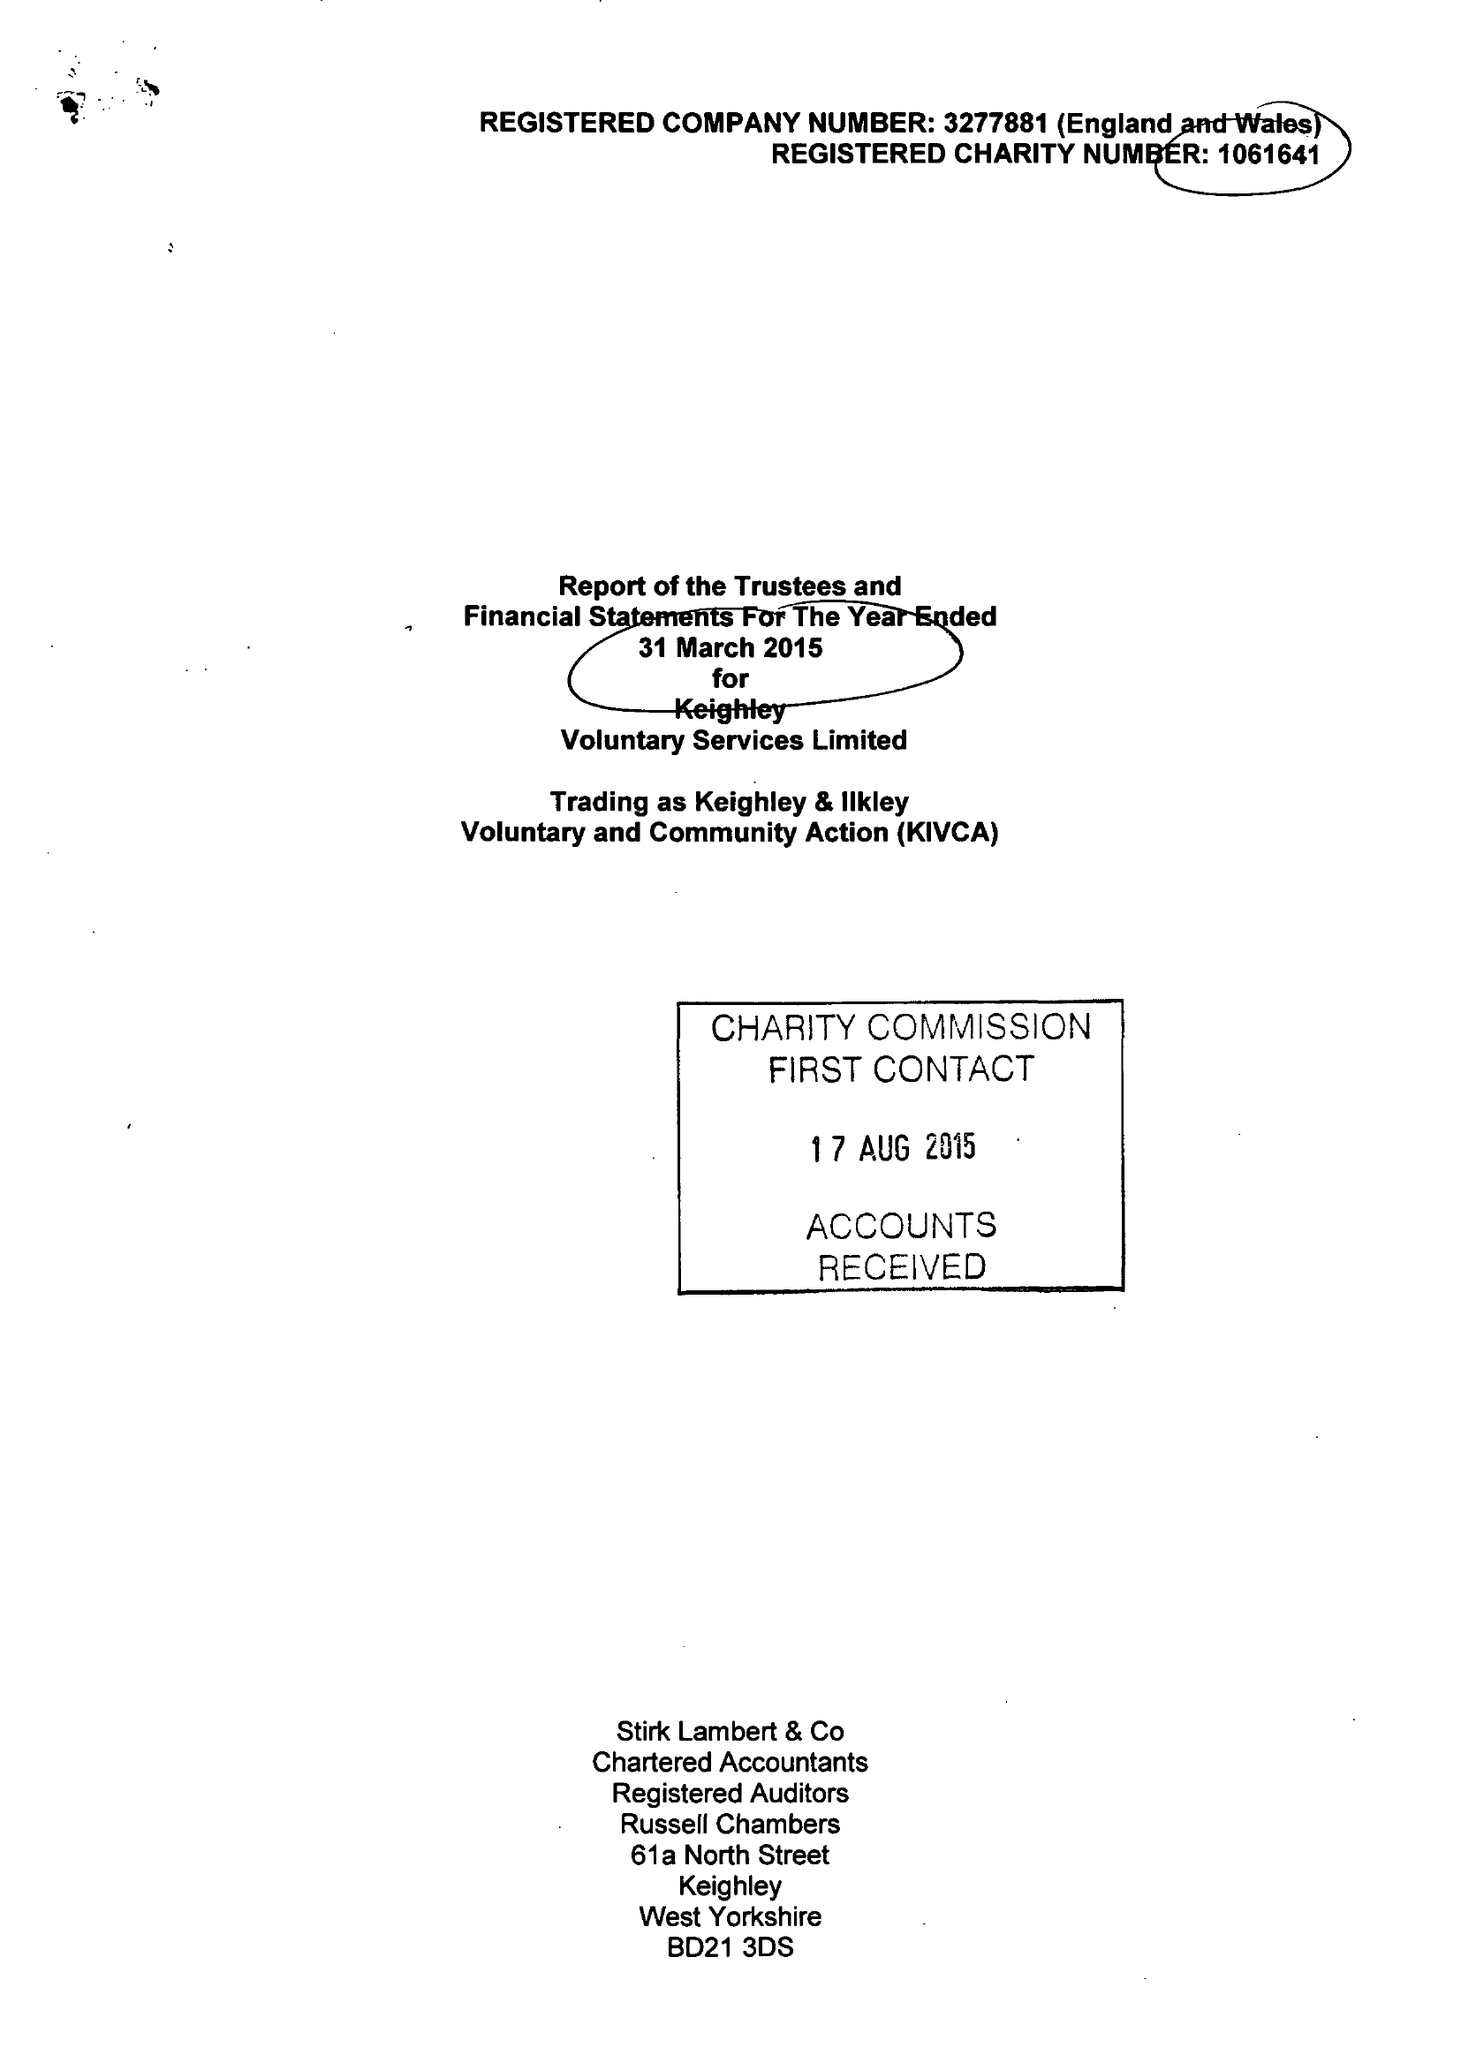What is the value for the address__post_town?
Answer the question using a single word or phrase. KEIGHLEY 